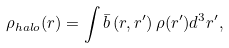Convert formula to latex. <formula><loc_0><loc_0><loc_500><loc_500>\rho _ { h a l o } ( r ) = \int \bar { b } \left ( r , r ^ { \prime } \right ) \rho ( r ^ { \prime } ) d ^ { 3 } r ^ { \prime } ,</formula> 